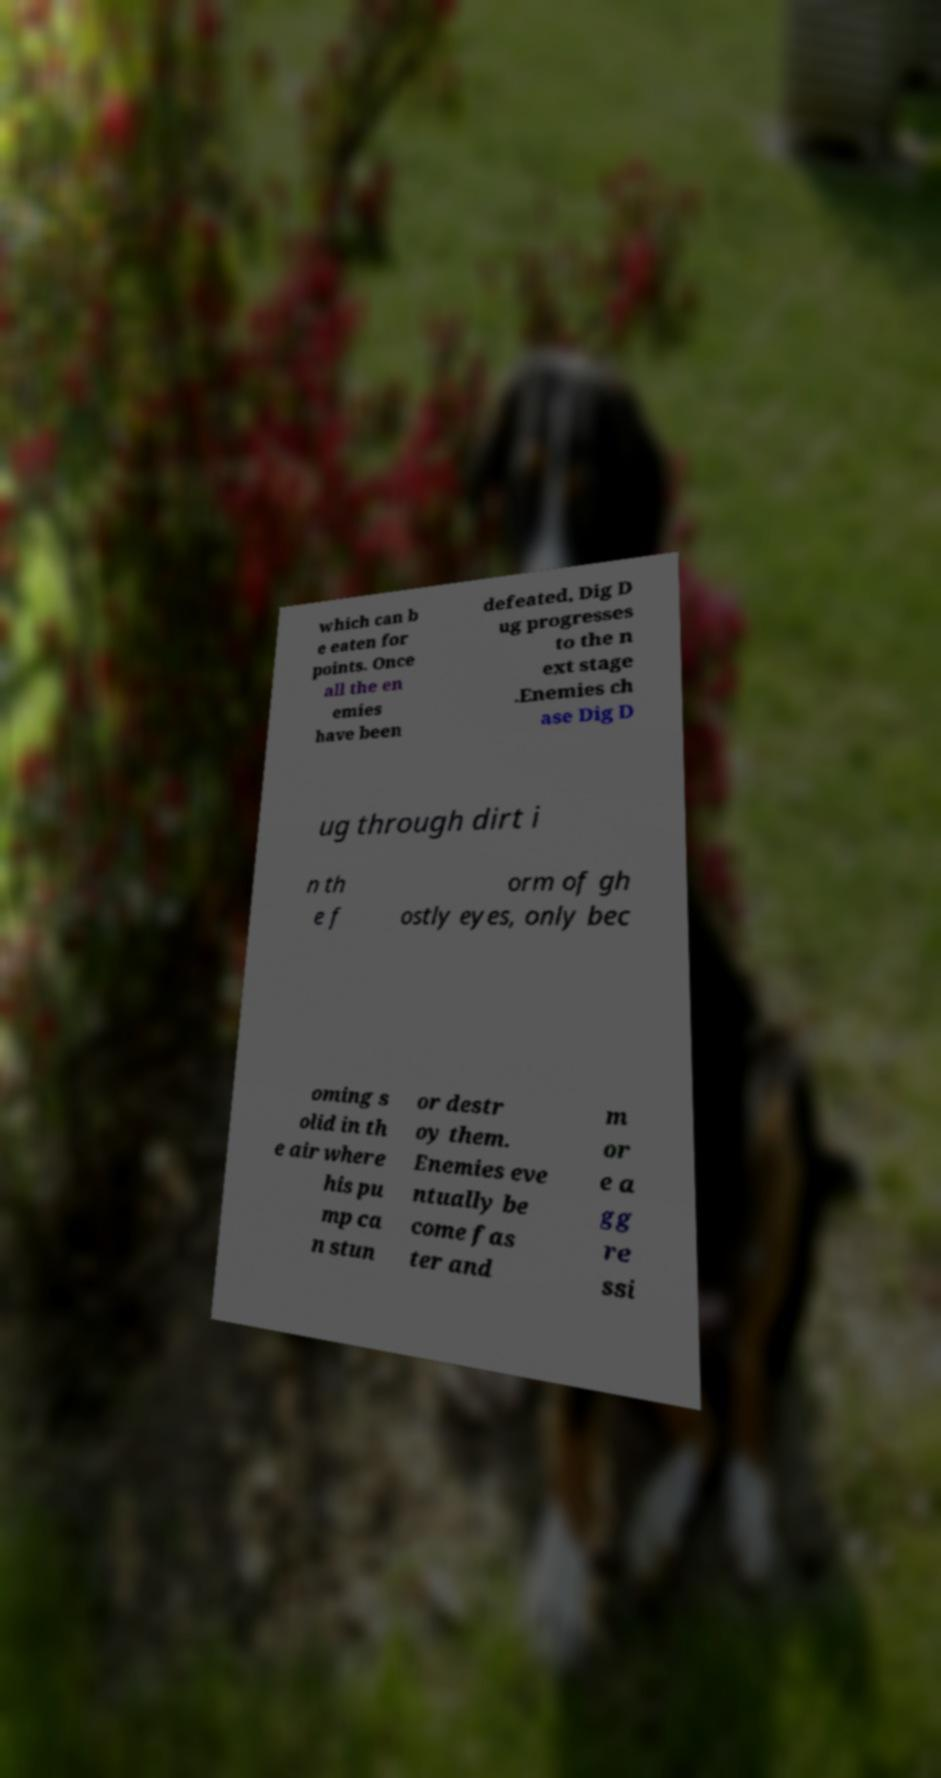Can you accurately transcribe the text from the provided image for me? which can b e eaten for points. Once all the en emies have been defeated, Dig D ug progresses to the n ext stage .Enemies ch ase Dig D ug through dirt i n th e f orm of gh ostly eyes, only bec oming s olid in th e air where his pu mp ca n stun or destr oy them. Enemies eve ntually be come fas ter and m or e a gg re ssi 